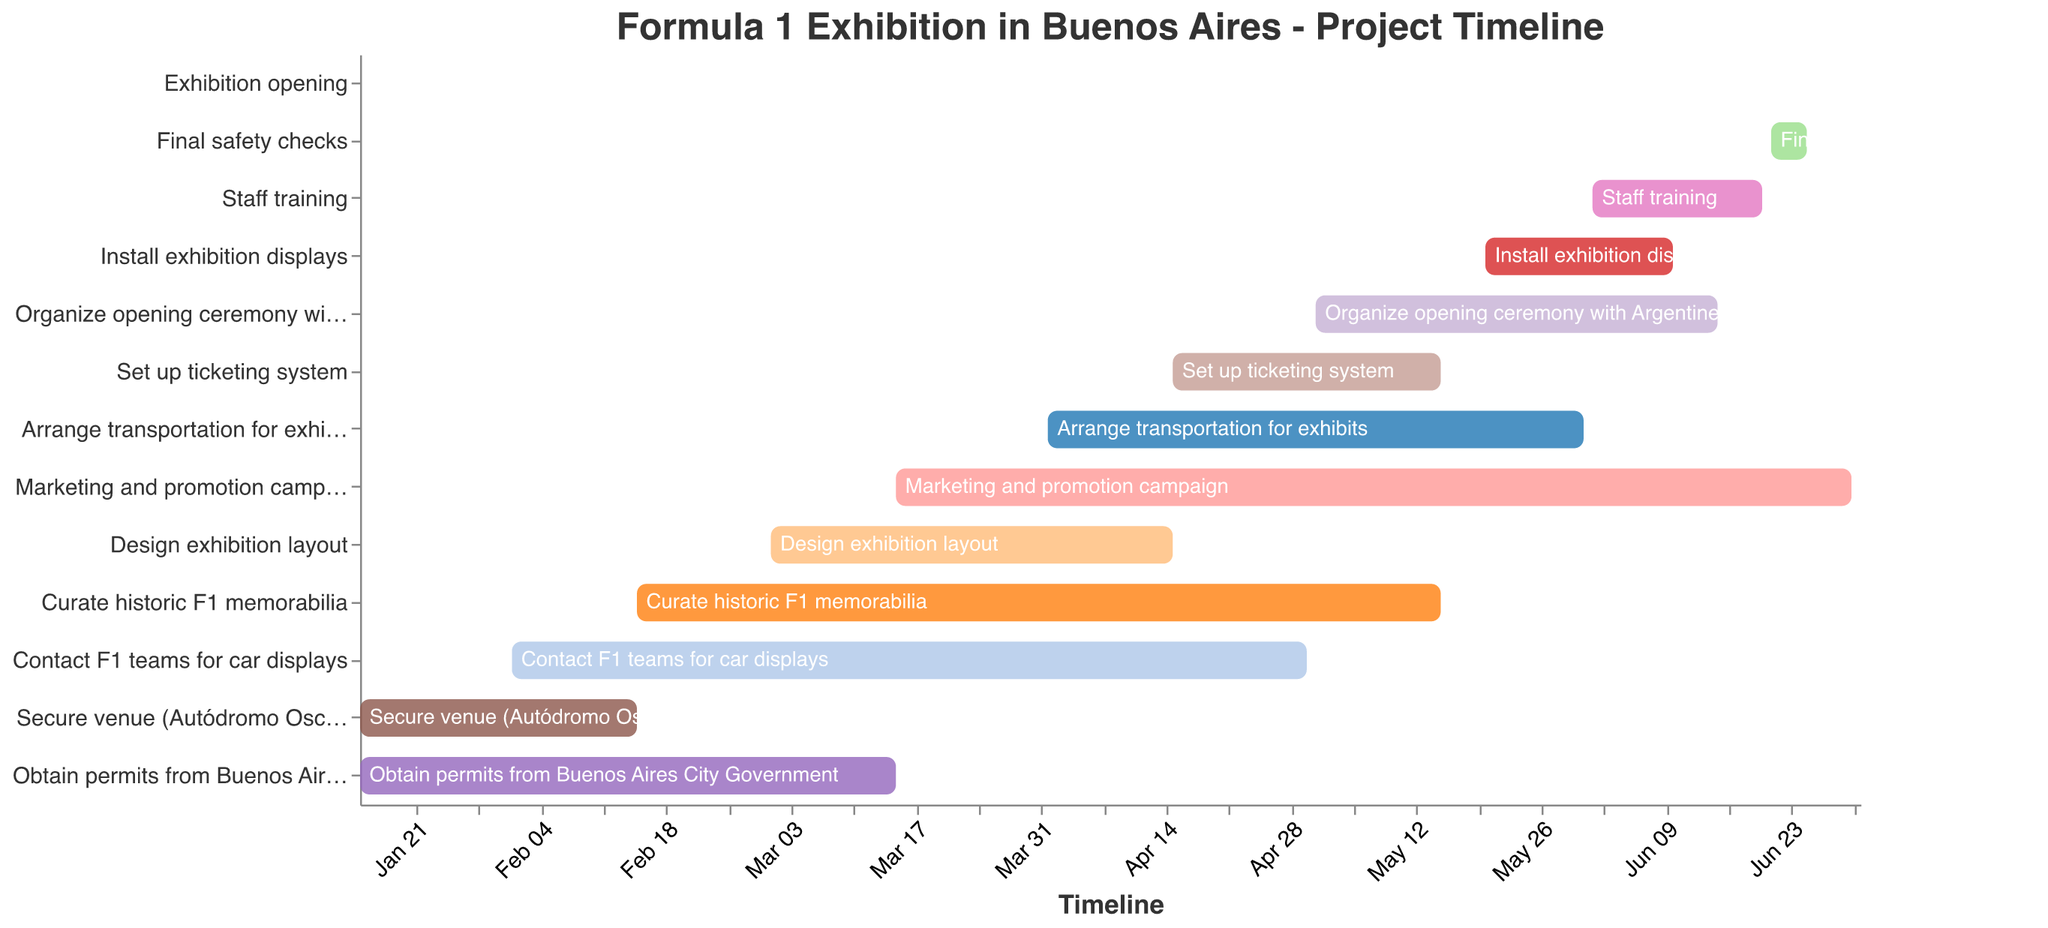What is the first task in the timeline? The Gantt chart starts on January 15th, 2024, with "Secure venue (Autódromo Oscar y Juan Gálvez)" as the first task from the top.
Answer: Secure venue (Autódromo Oscar y Juan Gálvez) How long does it take to obtain permits from the Buenos Aires City Government? Looking at the duration bar for "Obtain permits from Buenos Aires City Government," it spans from January 15th, 2024, to March 15th, 2024, which is a total duration of 60 days.
Answer: 60 days Which task has the longest duration before the exhibition opens? By comparing the durations of all tasks, "Marketing and promotion campaign" is the longest because it lasts for 107 days from March 15th, 2024, to June 30th, 2024.
Answer: Marketing and promotion campaign When does the "Install exhibition displays" task begin and end? The Gantt chart shows that "Install exhibition displays" starts on May 20th, 2024, and ends on June 10th, 2024.
Answer: May 20th, 2024 to June 10th, 2024 How many days are allocated for the final safety checks before the exhibition opening? The final safety checks are scheduled from June 21st, 2024, to June 25th, 2024, which is a total of 4 days.
Answer: 4 days What is the overlap period between "Organize opening ceremony with Argentine F1 legends" and "Staff training"? "Organize opening ceremony with Argentine F1 legends" runs from May 1st, 2024, to June 15th, 2024. "Staff training" is from June 1st, 2024, to June 20th, 2024. The overlapped period is from June 1st, 2024, to June 15th, 2024.
Answer: June 1st, 2024 to June 15th, 2024 Which tasks are scheduled to end on the same day? There are two tasks ending on the same day, which is May 15th, 2024. They are "Curate historic F1 memorabilia" and "Set up ticketing system."
Answer: Curate historic F1 memorabilia, Set up ticketing system Which task immediately follows the completion of "Contact F1 teams for car displays"? "Contact F1 teams for car displays" ends on April 30th, 2024. The next task starting closely afterward is "Arrange transportation for exhibits," which begins on April 1st, 2024, slightly overlapping but immediately proceeding.
Answer: Arrange transportation for exhibits What is the duration difference between the shortest task and the longest task? The shortest task is "Exhibition opening," with a duration of 1 day. The longest is "Marketing and promotion campaign," with a duration of 107 days. The difference is 107 - 1 = 106 days.
Answer: 106 days Which tasks are active during the first week of June 2024? During the first week of June 2024, the active tasks include "Install exhibition displays" (May 20, 2024 - June 10, 2024), "Staff training" (June 1, 2024 - June 20, 2024), "Marketing and promotion campaign" (March 15, 2024 - June 30, 2024), and "Organize opening ceremony with Argentine F1 legends" (May 1, 2024 - June 15, 2024).
Answer: Install exhibition displays, Staff training, Marketing and promotion campaign, Organize opening ceremony with Argentine F1 legends 